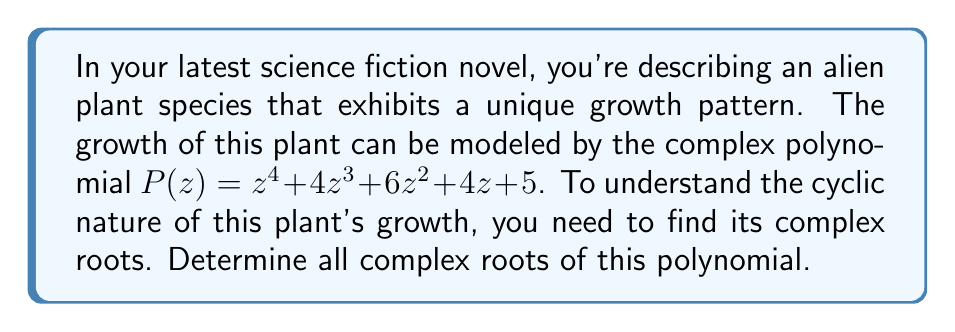Provide a solution to this math problem. To find the complex roots of the polynomial $P(z) = z^4 + 4z^3 + 6z^2 + 4z + 5$, we can follow these steps:

1) First, we notice that this polynomial is similar to $(z+1)^4$, which expands to $z^4 + 4z^3 + 6z^2 + 4z + 1$. Our polynomial differs only in the constant term.

2) Let's make a substitution: $w = z + 1$. This transforms our polynomial into:

   $P(w-1) = (w-1)^4 + 4(w-1)^3 + 6(w-1)^2 + 4(w-1) + 5$

3) Expanding this:
   
   $P(w-1) = w^4 - 4w^3 + 6w^2 - 4w + 1 + 4w^3 - 12w^2 + 12w - 4 + 6w^2 - 12w + 6 + 4w - 4 + 5$

4) Simplifying:

   $P(w-1) = w^4 + 4$

5) Now we can easily solve $w^4 = -4$:

   $w = \sqrt[4]{4} \cdot e^{i(2k+1)\pi/4}$, where $k = 0, 1, 2, 3$

6) The four roots are:

   $w_1 = \sqrt[4]{4} \cdot e^{i\pi/4}$
   $w_2 = \sqrt[4]{4} \cdot e^{3i\pi/4}$
   $w_3 = \sqrt[4]{4} \cdot e^{5i\pi/4}$
   $w_4 = \sqrt[4]{4} \cdot e^{7i\pi/4}$

7) Remember that $w = z + 1$, so we need to subtract 1 from each of these roots to get our final answer:

   $z_1 = \sqrt[4]{4} \cdot e^{i\pi/4} - 1$
   $z_2 = \sqrt[4]{4} \cdot e^{3i\pi/4} - 1$
   $z_3 = \sqrt[4]{4} \cdot e^{5i\pi/4} - 1$
   $z_4 = \sqrt[4]{4} \cdot e^{7i\pi/4} - 1$

These complex roots represent the cyclic nature of the alien plant's growth pattern in your story.
Answer: The four complex roots of the polynomial $P(z) = z^4 + 4z^3 + 6z^2 + 4z + 5$ are:

$z_1 = \sqrt[4]{4} \cdot e^{i\pi/4} - 1$
$z_2 = \sqrt[4]{4} \cdot e^{3i\pi/4} - 1$
$z_3 = \sqrt[4]{4} \cdot e^{5i\pi/4} - 1$
$z_4 = \sqrt[4]{4} \cdot e^{7i\pi/4} - 1$ 